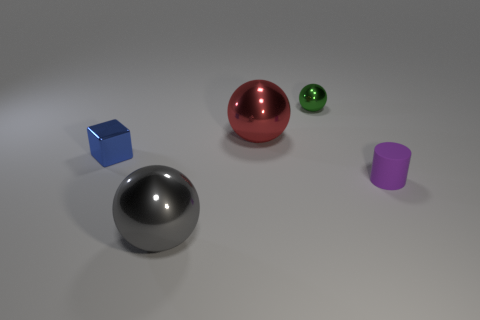Subtract 1 spheres. How many spheres are left? 2 Add 4 small metal cubes. How many objects exist? 9 Subtract all blocks. How many objects are left? 4 Subtract 0 gray cubes. How many objects are left? 5 Subtract all tiny gray rubber cylinders. Subtract all small green metallic objects. How many objects are left? 4 Add 2 large gray shiny objects. How many large gray shiny objects are left? 3 Add 4 green shiny objects. How many green shiny objects exist? 5 